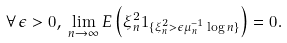Convert formula to latex. <formula><loc_0><loc_0><loc_500><loc_500>\forall \, \epsilon > 0 , \, \lim _ { n \rightarrow \infty } E \left ( \xi _ { n } ^ { 2 } 1 _ { \{ \xi _ { n } ^ { 2 } > \epsilon \mu _ { n } ^ { - 1 } \log n \} } \right ) = 0 .</formula> 